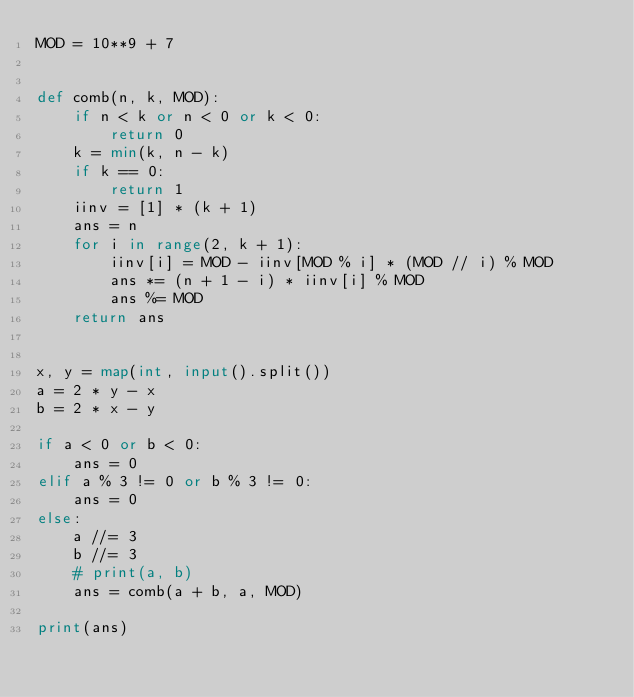Convert code to text. <code><loc_0><loc_0><loc_500><loc_500><_Python_>MOD = 10**9 + 7


def comb(n, k, MOD):
    if n < k or n < 0 or k < 0:
        return 0
    k = min(k, n - k)
    if k == 0:
        return 1
    iinv = [1] * (k + 1)
    ans = n
    for i in range(2, k + 1):
        iinv[i] = MOD - iinv[MOD % i] * (MOD // i) % MOD
        ans *= (n + 1 - i) * iinv[i] % MOD
        ans %= MOD
    return ans


x, y = map(int, input().split())
a = 2 * y - x
b = 2 * x - y

if a < 0 or b < 0:
    ans = 0
elif a % 3 != 0 or b % 3 != 0:
    ans = 0
else:
    a //= 3
    b //= 3
    # print(a, b)
    ans = comb(a + b, a, MOD)

print(ans)
</code> 